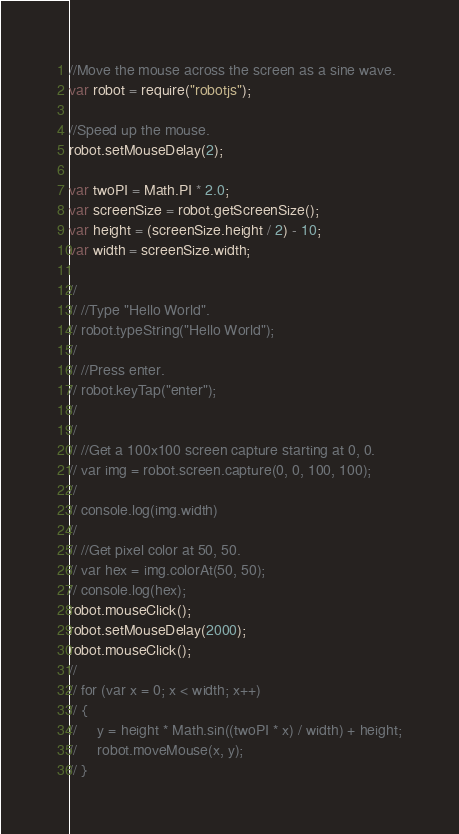<code> <loc_0><loc_0><loc_500><loc_500><_JavaScript_>//Move the mouse across the screen as a sine wave.
var robot = require("robotjs");

//Speed up the mouse.
robot.setMouseDelay(2);

var twoPI = Math.PI * 2.0;
var screenSize = robot.getScreenSize();
var height = (screenSize.height / 2) - 10;
var width = screenSize.width;

//
// //Type "Hello World".
// robot.typeString("Hello World");
//
// //Press enter.
// robot.keyTap("enter");
//
//
// //Get a 100x100 screen capture starting at 0, 0.
// var img = robot.screen.capture(0, 0, 100, 100);
//
// console.log(img.width)
//
// //Get pixel color at 50, 50.
// var hex = img.colorAt(50, 50);
// console.log(hex);
robot.mouseClick();
robot.setMouseDelay(2000);
robot.mouseClick();
//
// for (var x = 0; x < width; x++)
// {
//     y = height * Math.sin((twoPI * x) / width) + height;
//     robot.moveMouse(x, y);
// }</code> 